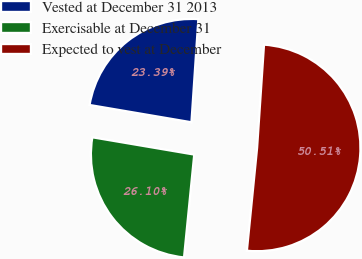<chart> <loc_0><loc_0><loc_500><loc_500><pie_chart><fcel>Vested at December 31 2013<fcel>Exercisable at December 31<fcel>Expected to vest at December<nl><fcel>23.39%<fcel>26.1%<fcel>50.51%<nl></chart> 